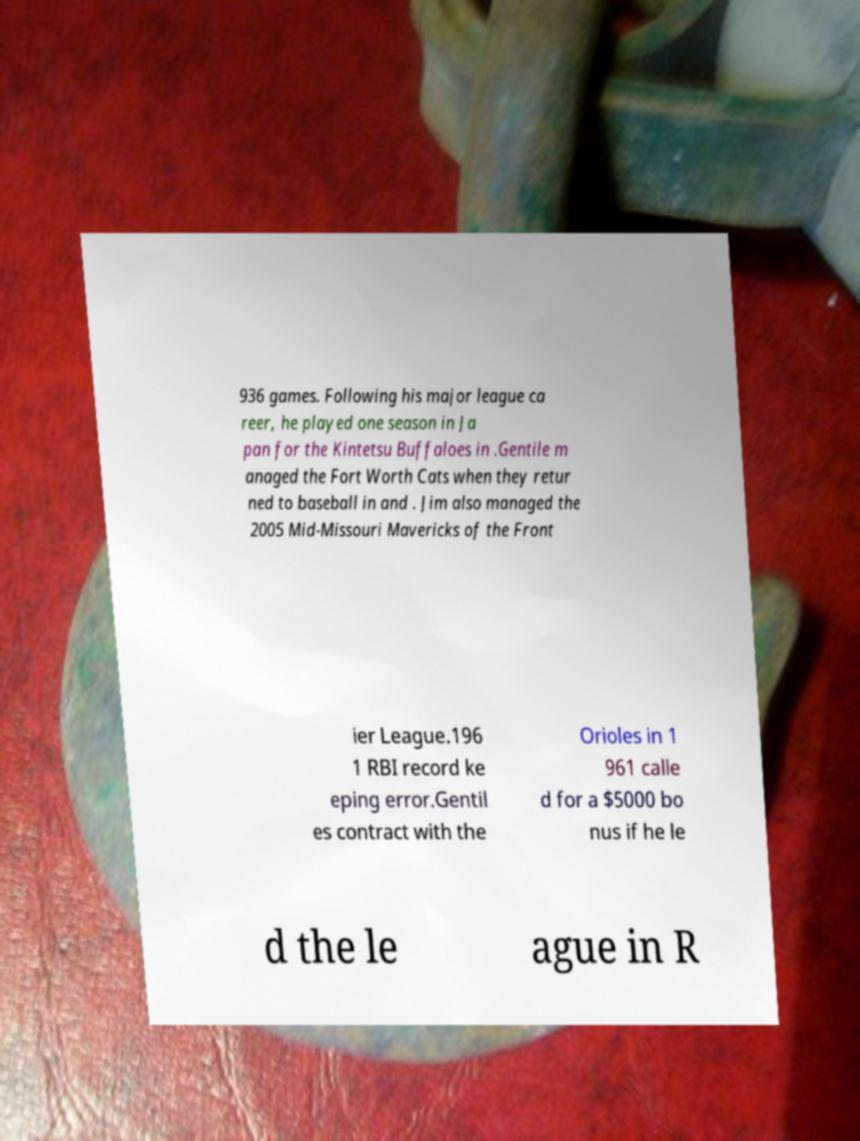There's text embedded in this image that I need extracted. Can you transcribe it verbatim? 936 games. Following his major league ca reer, he played one season in Ja pan for the Kintetsu Buffaloes in .Gentile m anaged the Fort Worth Cats when they retur ned to baseball in and . Jim also managed the 2005 Mid-Missouri Mavericks of the Front ier League.196 1 RBI record ke eping error.Gentil es contract with the Orioles in 1 961 calle d for a $5000 bo nus if he le d the le ague in R 